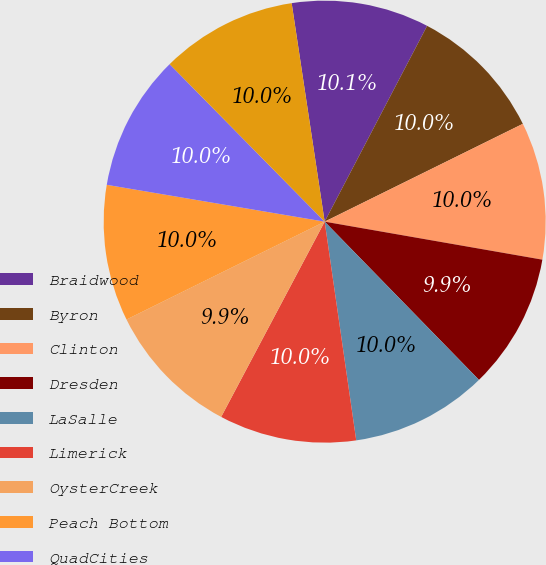Convert chart. <chart><loc_0><loc_0><loc_500><loc_500><pie_chart><fcel>Braidwood<fcel>Byron<fcel>Clinton<fcel>Dresden<fcel>LaSalle<fcel>Limerick<fcel>OysterCreek<fcel>Peach Bottom<fcel>QuadCities<fcel>Salem<nl><fcel>10.06%<fcel>10.03%<fcel>10.05%<fcel>9.95%<fcel>10.02%<fcel>10.04%<fcel>9.94%<fcel>9.97%<fcel>9.96%<fcel>9.99%<nl></chart> 